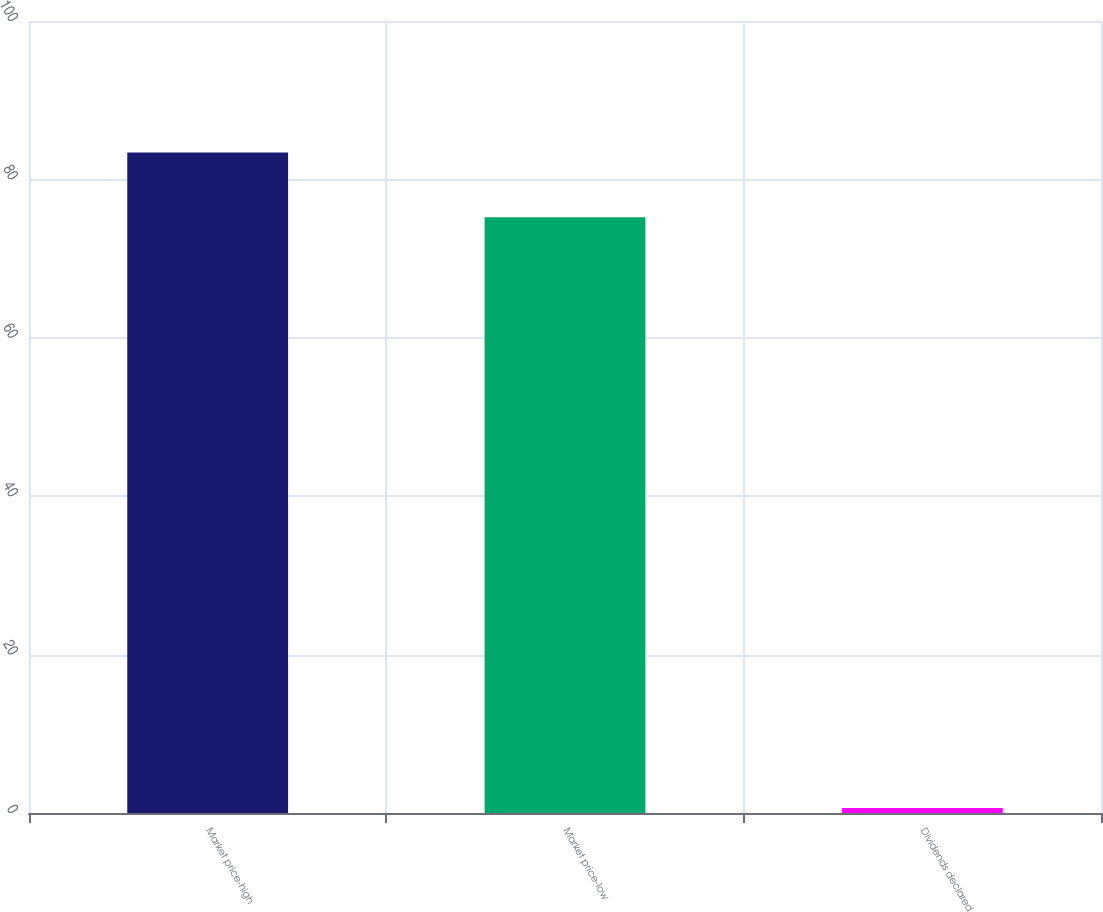<chart> <loc_0><loc_0><loc_500><loc_500><bar_chart><fcel>Market price-high<fcel>Market price-low<fcel>Dividends declared<nl><fcel>83.4<fcel>75.21<fcel>0.62<nl></chart> 